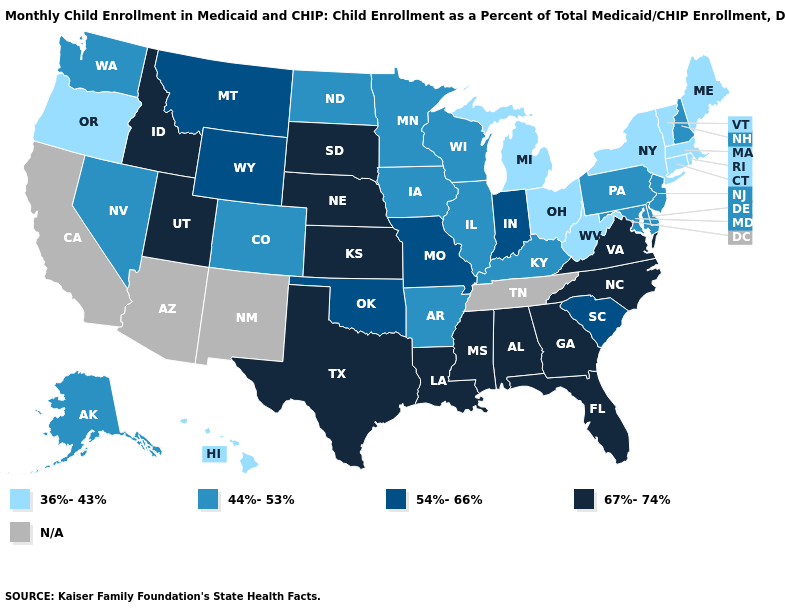Name the states that have a value in the range 36%-43%?
Concise answer only. Connecticut, Hawaii, Maine, Massachusetts, Michigan, New York, Ohio, Oregon, Rhode Island, Vermont, West Virginia. Among the states that border Arkansas , which have the highest value?
Be succinct. Louisiana, Mississippi, Texas. What is the value of Michigan?
Write a very short answer. 36%-43%. Is the legend a continuous bar?
Write a very short answer. No. Name the states that have a value in the range 54%-66%?
Short answer required. Indiana, Missouri, Montana, Oklahoma, South Carolina, Wyoming. What is the value of Kentucky?
Be succinct. 44%-53%. Does New Jersey have the lowest value in the Northeast?
Keep it brief. No. Does Virginia have the highest value in the USA?
Keep it brief. Yes. How many symbols are there in the legend?
Write a very short answer. 5. Is the legend a continuous bar?
Answer briefly. No. Name the states that have a value in the range 54%-66%?
Answer briefly. Indiana, Missouri, Montana, Oklahoma, South Carolina, Wyoming. What is the value of Wisconsin?
Quick response, please. 44%-53%. Name the states that have a value in the range N/A?
Quick response, please. Arizona, California, New Mexico, Tennessee. What is the value of Georgia?
Give a very brief answer. 67%-74%. Which states have the highest value in the USA?
Write a very short answer. Alabama, Florida, Georgia, Idaho, Kansas, Louisiana, Mississippi, Nebraska, North Carolina, South Dakota, Texas, Utah, Virginia. 